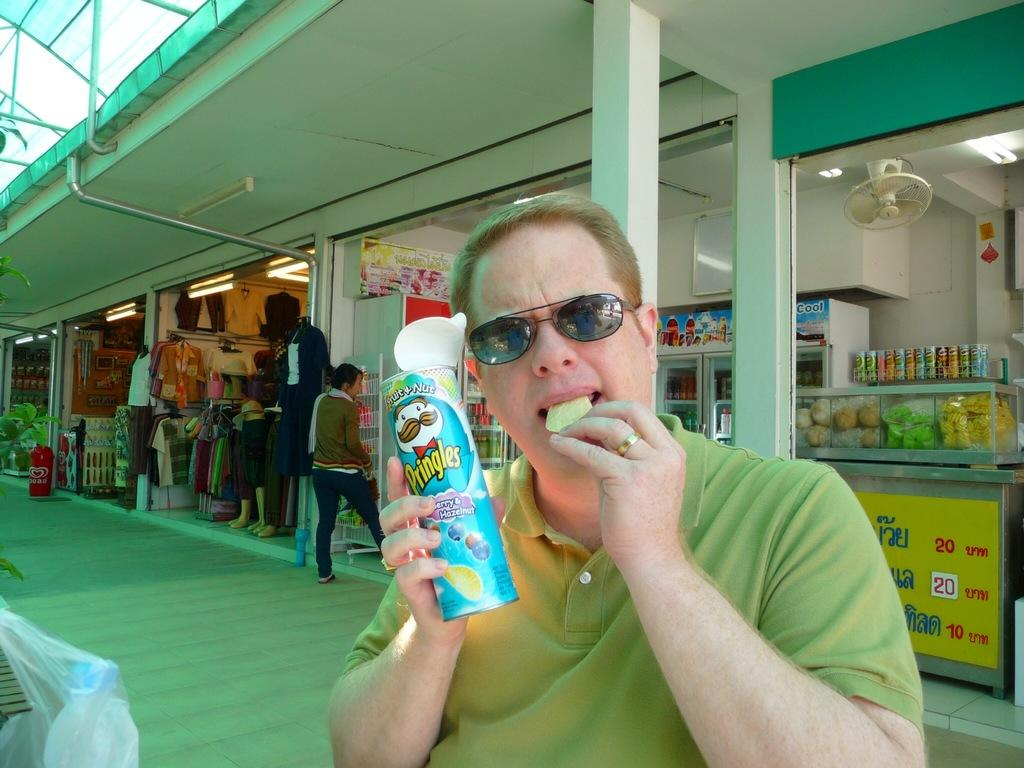How many people are in the image? There are people in the image. Can you describe the clothing of one of the individuals? A man is wearing a red t-shirt. What is the man holding in the image? The man is holding a bottle. What type of items can be seen in the image besides people? There are food items and a fan in the image. What type of establishment can be seen in the image? There are shops in the image. What type of parent is visible in the image? There is no mention of a parent or any parent-child relationship in the image. Can you describe how the man is touching the bottle in the image? The image does not show the man touching the bottle, only holding it. 